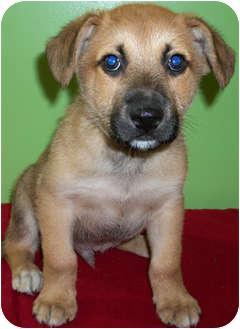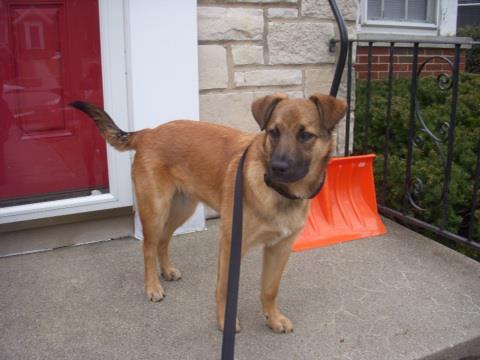The first image is the image on the left, the second image is the image on the right. Assess this claim about the two images: "An image shows a black dog with erect, pointed ears.". Correct or not? Answer yes or no. No. 